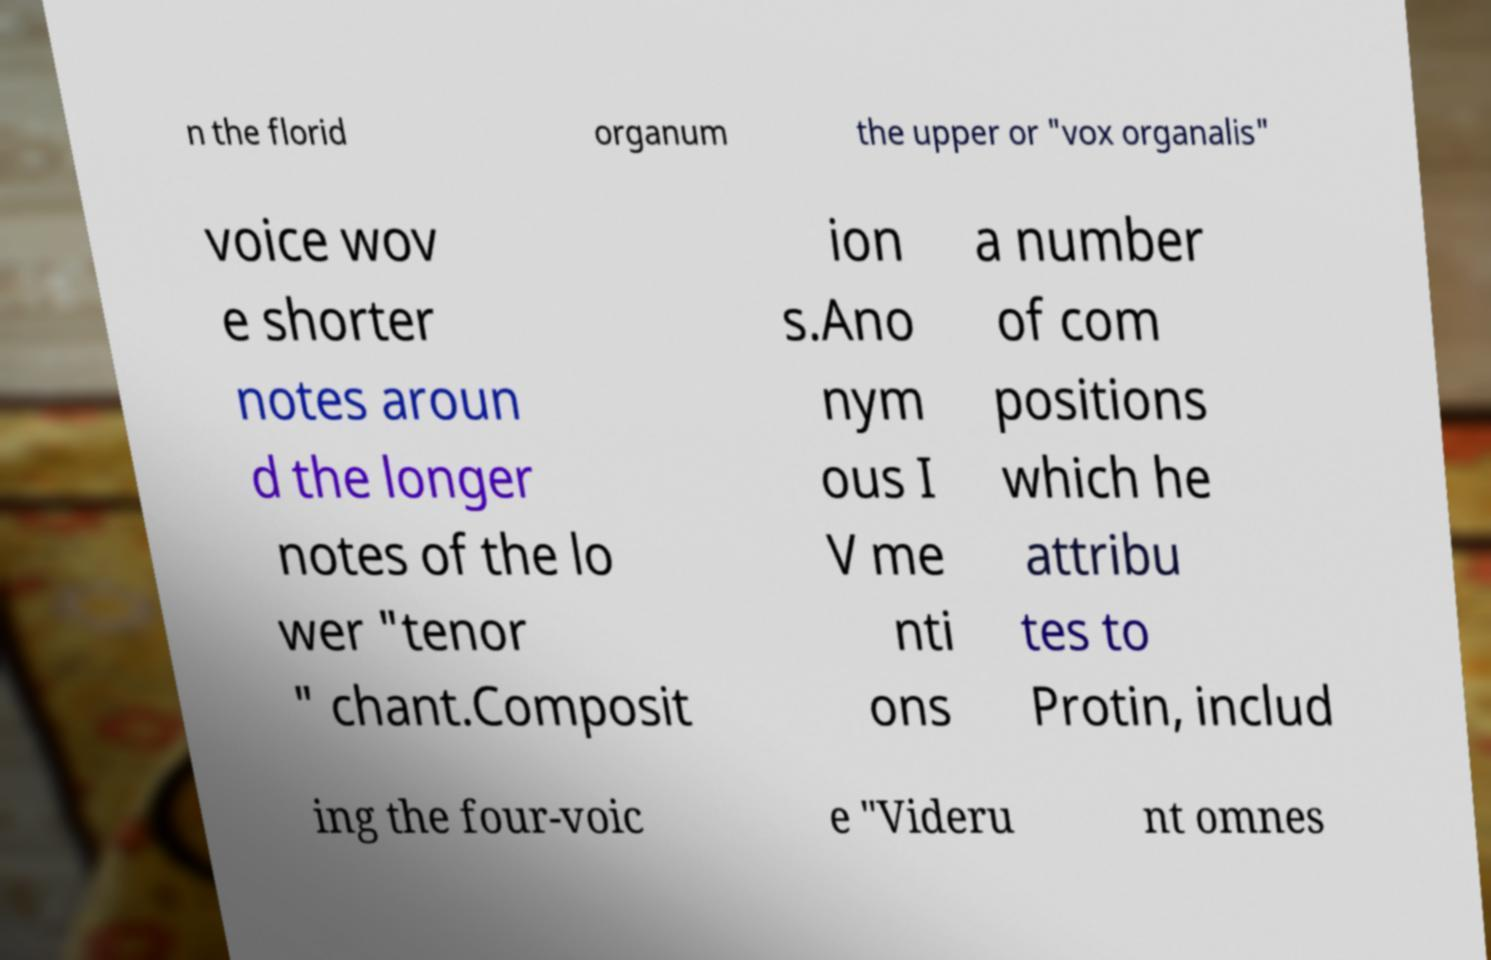Can you read and provide the text displayed in the image?This photo seems to have some interesting text. Can you extract and type it out for me? n the florid organum the upper or "vox organalis" voice wov e shorter notes aroun d the longer notes of the lo wer "tenor " chant.Composit ion s.Ano nym ous I V me nti ons a number of com positions which he attribu tes to Protin, includ ing the four-voic e "Videru nt omnes 